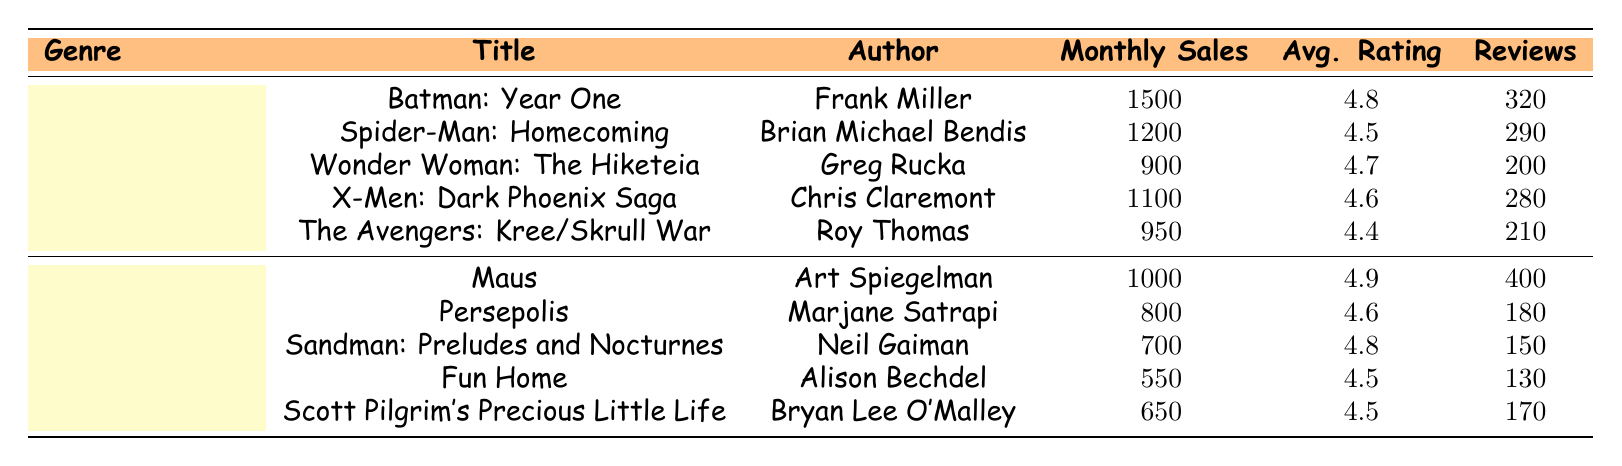What is the monthly sales of "Batman: Year One"? The table shows that "Batman: Year One" has monthly sales of 1500.
Answer: 1500 Which non-superhero comic has the highest average rating? Looking at the non-superhero genre, "Maus" has the highest average rating of 4.9 compared to the others: Persepolis (4.6), Sandman: Preludes and Nocturnes (4.8), Fun Home (4.5), and Scott Pilgrim's Precious Little Life (4.5).
Answer: Maus What is the total monthly sales of all superhero comics listed? Adding the monthly sales of all superhero comics: 1500 (Batman: Year One) + 1200 (Spider-Man: Homecoming) + 900 (Wonder Woman: The Hiketeia) + 1100 (X-Men: Dark Phoenix Saga) + 950 (The Avengers: Kree/Skrull War) gives a total of 4850.
Answer: 4850 Is the average rating of "Persepolis" higher than that of "Fun Home"? "Persepolis" has an average rating of 4.6 while "Fun Home" has a rating of 4.5. Thus, the average rating of "Persepolis" is indeed higher than "Fun Home."
Answer: Yes How many customer reviews does the highest selling non-superhero title have? The highest selling non-superhero title is "Maus" with monthly sales of 1000, and it has 400 customer reviews.
Answer: 400 Which superhero comic has the lowest sales and what is its title? The superhero comic with the lowest sales is "The Avengers: Kree/Skrull War," with monthly sales of 950.
Answer: The Avengers: Kree/Skrull War What is the difference in monthly sales between the highest and lowest selling superhero comics? The highest selling superhero comic is "Batman: Year One" with 1500 monthly sales, and the lowest is "The Avengers: Kree/Skrull War" with 950. The difference is 1500 - 950 = 550.
Answer: 550 Which genre has a higher average rating overall, superhero or non-superhero? The average ratings for the superhero comics are (4.8 + 4.5 + 4.7 + 4.6 + 4.4)/5 = 4.6. The average ratings for the non-superhero comics are (4.9 + 4.6 + 4.8 + 4.5 + 4.5)/5 = 4.66. Since 4.66 is higher than 4.6, non-superhero comics have a higher average rating.
Answer: Non-superhero How many superhero comics have monthly sales above 1000? The superhero comics with sales above 1000 are "Batman: Year One" (1500), "Spider-Man: Homecoming" (1200), and "X-Men: Dark Phoenix Saga" (1100). This totals to three superhero comics.
Answer: 3 